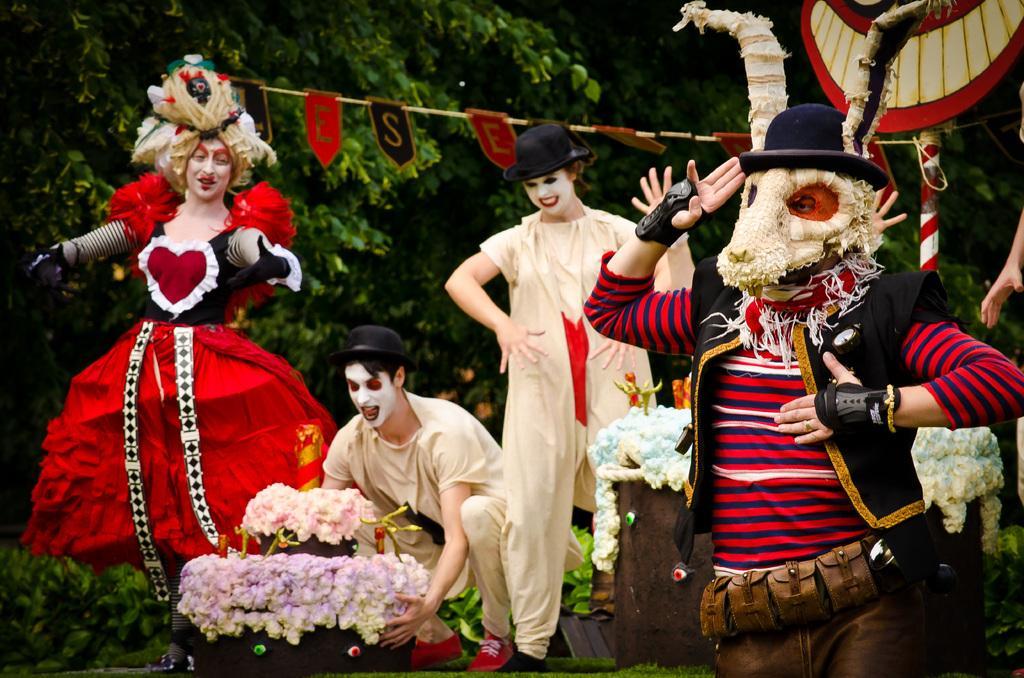In one or two sentences, can you explain what this image depicts? This picture is clicked outside. In the center we can see the group of people wearing different dresses, standing on the ground and seems to be dancing. In the center there is a person squatting on the ground and holding some objects. In the background we can see the rope and the letters are hanging on the rope and we can see the trees and flowers and some other objects. 